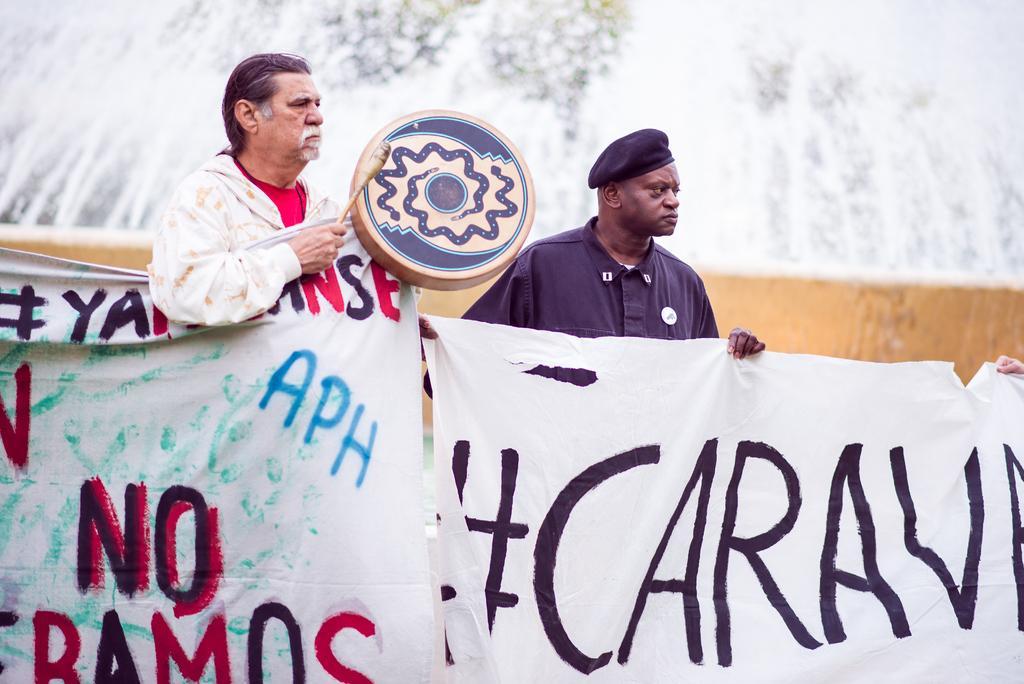Describe this image in one or two sentences. In this image we can see two men standing and holding advertisements in their hands and one of them is holding a drum in his hands. 